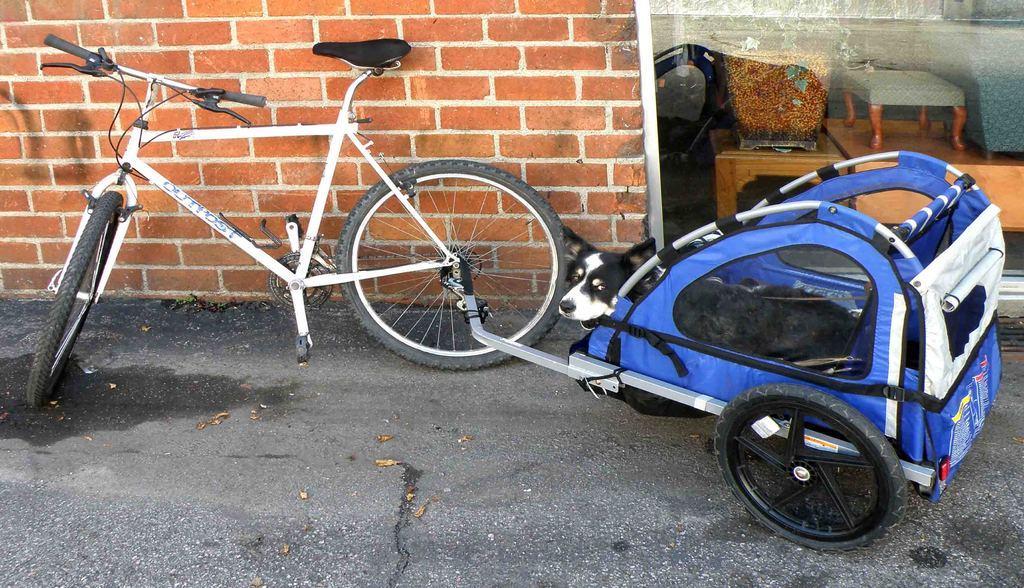Could you give a brief overview of what you see in this image? In this image in the front there is a cart and there is a dog sitting in the cart and there is a bicycle. In the background there is a wall and there is a glass, behind the glass there is a stool and there is an object which is brown in colour and there are tables and on the tables, there is sofa, stool and object. In the front on the ground there are dry leaves. 